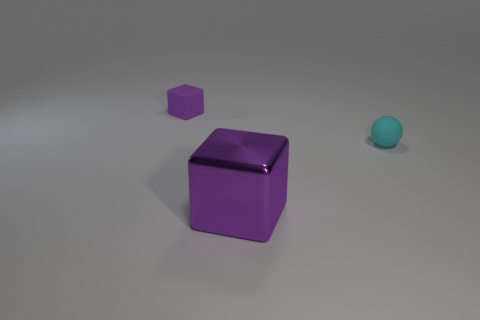Add 1 small purple things. How many objects exist? 4 Subtract all spheres. How many objects are left? 2 Subtract all tiny purple things. Subtract all small rubber cubes. How many objects are left? 1 Add 1 purple metallic things. How many purple metallic things are left? 2 Add 3 large red objects. How many large red objects exist? 3 Subtract 0 gray blocks. How many objects are left? 3 